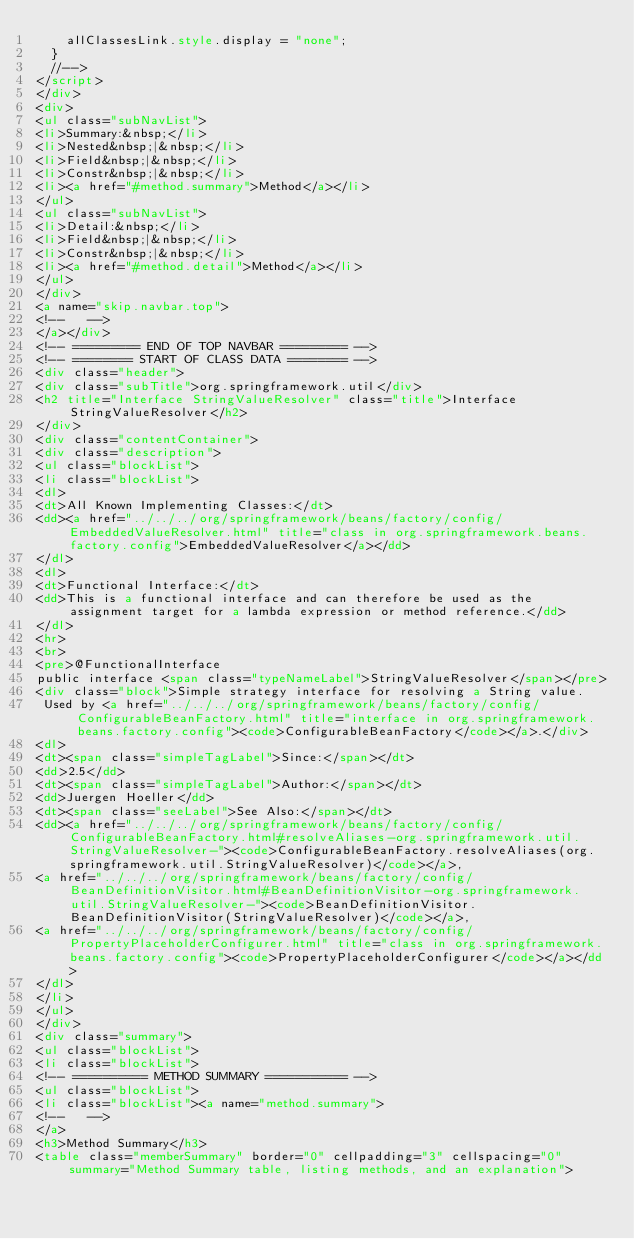Convert code to text. <code><loc_0><loc_0><loc_500><loc_500><_HTML_>    allClassesLink.style.display = "none";
  }
  //-->
</script>
</div>
<div>
<ul class="subNavList">
<li>Summary:&nbsp;</li>
<li>Nested&nbsp;|&nbsp;</li>
<li>Field&nbsp;|&nbsp;</li>
<li>Constr&nbsp;|&nbsp;</li>
<li><a href="#method.summary">Method</a></li>
</ul>
<ul class="subNavList">
<li>Detail:&nbsp;</li>
<li>Field&nbsp;|&nbsp;</li>
<li>Constr&nbsp;|&nbsp;</li>
<li><a href="#method.detail">Method</a></li>
</ul>
</div>
<a name="skip.navbar.top">
<!--   -->
</a></div>
<!-- ========= END OF TOP NAVBAR ========= -->
<!-- ======== START OF CLASS DATA ======== -->
<div class="header">
<div class="subTitle">org.springframework.util</div>
<h2 title="Interface StringValueResolver" class="title">Interface StringValueResolver</h2>
</div>
<div class="contentContainer">
<div class="description">
<ul class="blockList">
<li class="blockList">
<dl>
<dt>All Known Implementing Classes:</dt>
<dd><a href="../../../org/springframework/beans/factory/config/EmbeddedValueResolver.html" title="class in org.springframework.beans.factory.config">EmbeddedValueResolver</a></dd>
</dl>
<dl>
<dt>Functional Interface:</dt>
<dd>This is a functional interface and can therefore be used as the assignment target for a lambda expression or method reference.</dd>
</dl>
<hr>
<br>
<pre>@FunctionalInterface
public interface <span class="typeNameLabel">StringValueResolver</span></pre>
<div class="block">Simple strategy interface for resolving a String value.
 Used by <a href="../../../org/springframework/beans/factory/config/ConfigurableBeanFactory.html" title="interface in org.springframework.beans.factory.config"><code>ConfigurableBeanFactory</code></a>.</div>
<dl>
<dt><span class="simpleTagLabel">Since:</span></dt>
<dd>2.5</dd>
<dt><span class="simpleTagLabel">Author:</span></dt>
<dd>Juergen Hoeller</dd>
<dt><span class="seeLabel">See Also:</span></dt>
<dd><a href="../../../org/springframework/beans/factory/config/ConfigurableBeanFactory.html#resolveAliases-org.springframework.util.StringValueResolver-"><code>ConfigurableBeanFactory.resolveAliases(org.springframework.util.StringValueResolver)</code></a>, 
<a href="../../../org/springframework/beans/factory/config/BeanDefinitionVisitor.html#BeanDefinitionVisitor-org.springframework.util.StringValueResolver-"><code>BeanDefinitionVisitor.BeanDefinitionVisitor(StringValueResolver)</code></a>, 
<a href="../../../org/springframework/beans/factory/config/PropertyPlaceholderConfigurer.html" title="class in org.springframework.beans.factory.config"><code>PropertyPlaceholderConfigurer</code></a></dd>
</dl>
</li>
</ul>
</div>
<div class="summary">
<ul class="blockList">
<li class="blockList">
<!-- ========== METHOD SUMMARY =========== -->
<ul class="blockList">
<li class="blockList"><a name="method.summary">
<!--   -->
</a>
<h3>Method Summary</h3>
<table class="memberSummary" border="0" cellpadding="3" cellspacing="0" summary="Method Summary table, listing methods, and an explanation"></code> 